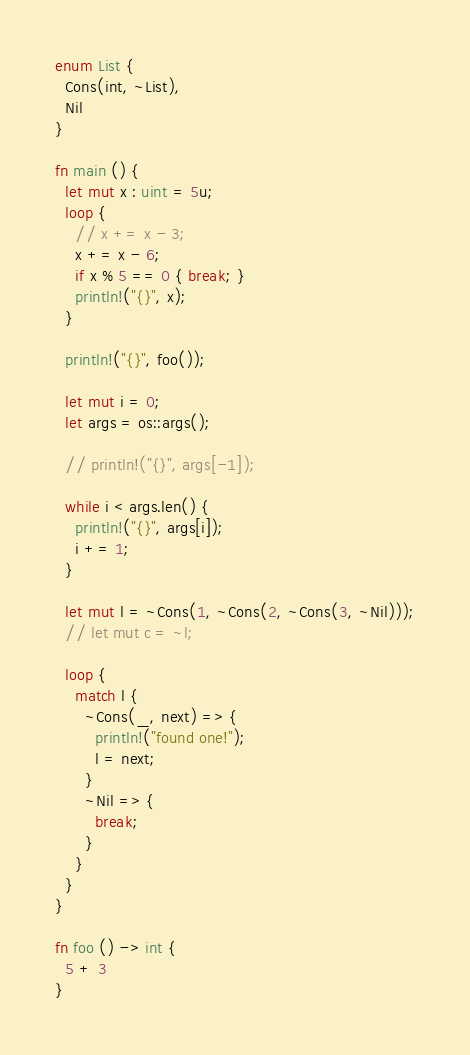Convert code to text. <code><loc_0><loc_0><loc_500><loc_500><_Rust_>enum List {
  Cons(int, ~List),
  Nil
}

fn main () {
  let mut x : uint = 5u;
  loop {
    // x += x - 3;
    x += x - 6;
    if x % 5 == 0 { break; }
    println!("{}", x);
  }

  println!("{}", foo());

  let mut i = 0;
  let args = os::args();

  // println!("{}", args[-1]);

  while i < args.len() {
    println!("{}", args[i]);
    i += 1;
  }

  let mut l = ~Cons(1, ~Cons(2, ~Cons(3, ~Nil)));
  // let mut c = ~l;

  loop {
    match l {
      ~Cons(_, next) => {
        println!("found one!");
        l = next;
      }
      ~Nil => {
        break;
      }
    }
  }
}

fn foo () -> int {
  5 + 3
}
</code> 